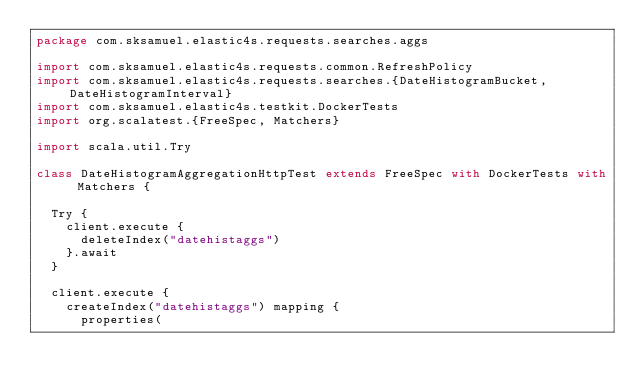Convert code to text. <code><loc_0><loc_0><loc_500><loc_500><_Scala_>package com.sksamuel.elastic4s.requests.searches.aggs

import com.sksamuel.elastic4s.requests.common.RefreshPolicy
import com.sksamuel.elastic4s.requests.searches.{DateHistogramBucket, DateHistogramInterval}
import com.sksamuel.elastic4s.testkit.DockerTests
import org.scalatest.{FreeSpec, Matchers}

import scala.util.Try

class DateHistogramAggregationHttpTest extends FreeSpec with DockerTests with Matchers {

  Try {
    client.execute {
      deleteIndex("datehistaggs")
    }.await
  }

  client.execute {
    createIndex("datehistaggs") mapping {
      properties(</code> 